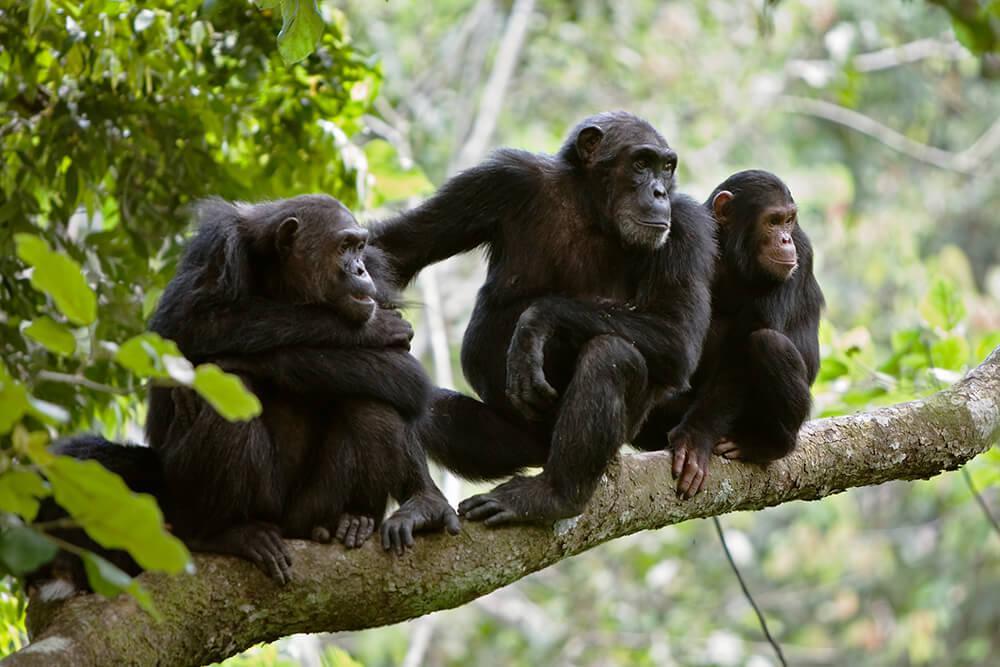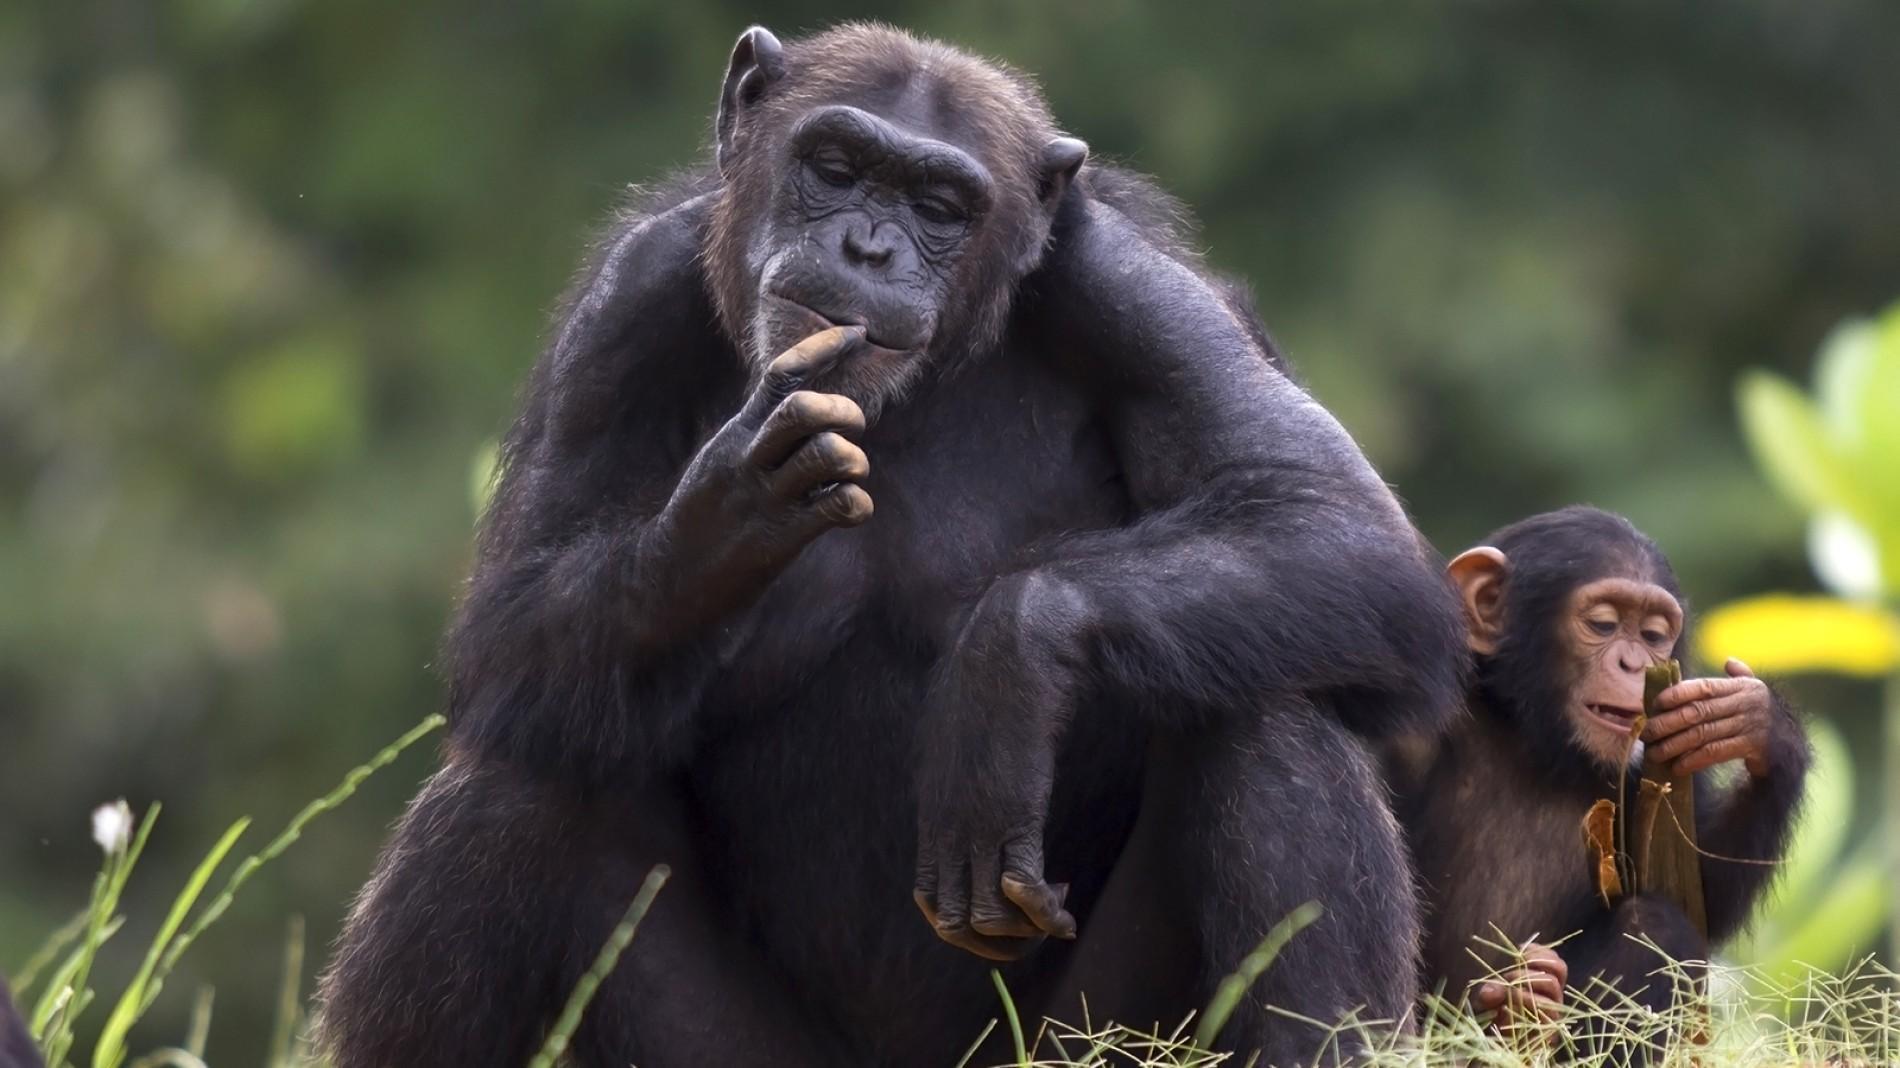The first image is the image on the left, the second image is the image on the right. Considering the images on both sides, is "The left image contains more chimps than the right image." valid? Answer yes or no. Yes. 